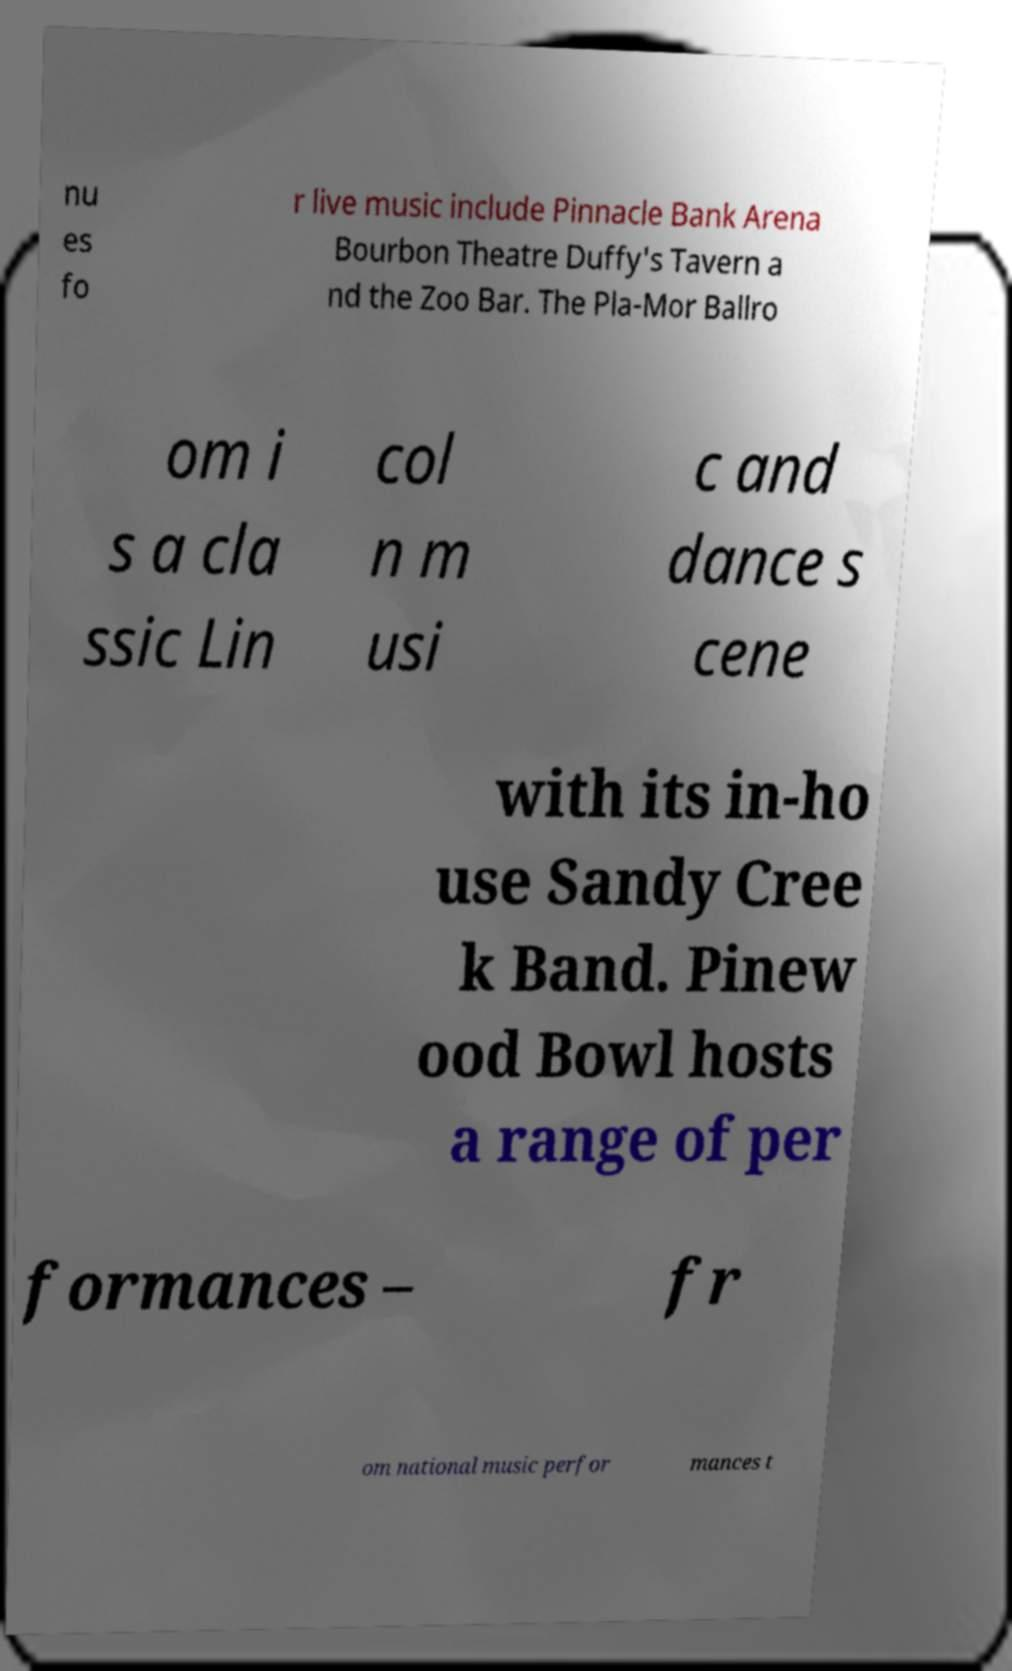Please identify and transcribe the text found in this image. nu es fo r live music include Pinnacle Bank Arena Bourbon Theatre Duffy's Tavern a nd the Zoo Bar. The Pla-Mor Ballro om i s a cla ssic Lin col n m usi c and dance s cene with its in-ho use Sandy Cree k Band. Pinew ood Bowl hosts a range of per formances – fr om national music perfor mances t 